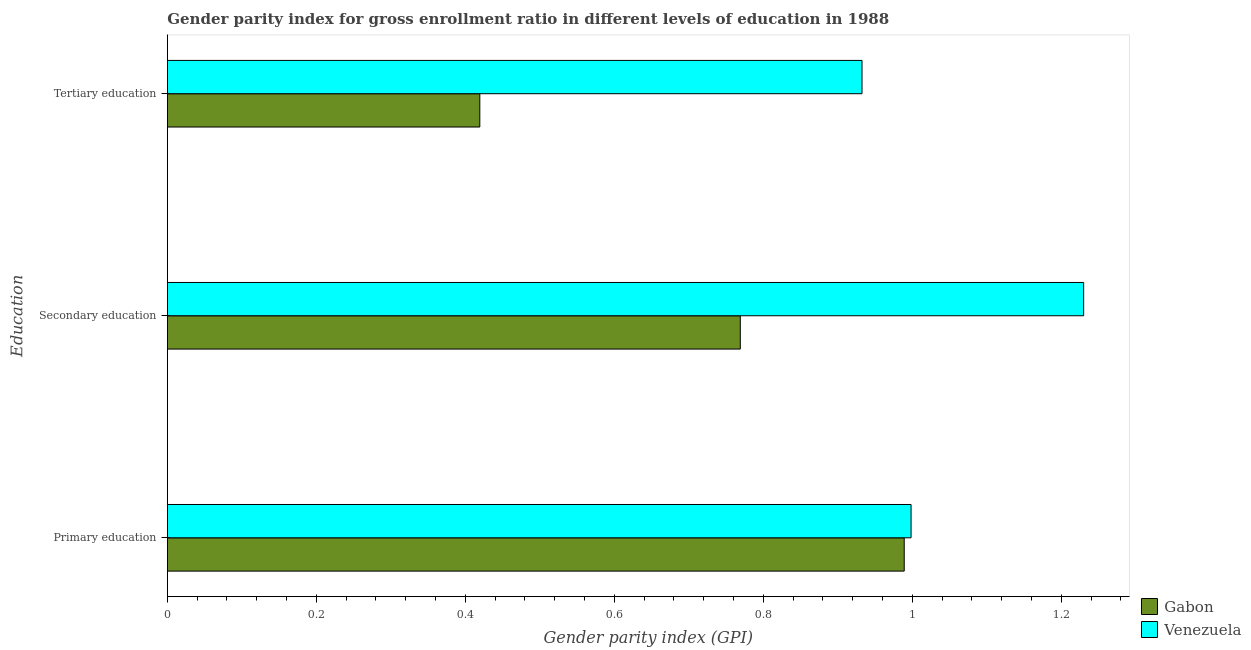How many groups of bars are there?
Offer a very short reply. 3. Are the number of bars on each tick of the Y-axis equal?
Provide a short and direct response. Yes. How many bars are there on the 1st tick from the top?
Your answer should be very brief. 2. What is the label of the 2nd group of bars from the top?
Provide a succinct answer. Secondary education. What is the gender parity index in primary education in Gabon?
Make the answer very short. 0.99. Across all countries, what is the maximum gender parity index in primary education?
Your response must be concise. 1. Across all countries, what is the minimum gender parity index in primary education?
Provide a short and direct response. 0.99. In which country was the gender parity index in primary education maximum?
Make the answer very short. Venezuela. In which country was the gender parity index in primary education minimum?
Keep it short and to the point. Gabon. What is the total gender parity index in primary education in the graph?
Provide a succinct answer. 1.99. What is the difference between the gender parity index in tertiary education in Gabon and that in Venezuela?
Provide a short and direct response. -0.51. What is the difference between the gender parity index in secondary education in Venezuela and the gender parity index in primary education in Gabon?
Offer a very short reply. 0.24. What is the average gender parity index in tertiary education per country?
Provide a short and direct response. 0.68. What is the difference between the gender parity index in secondary education and gender parity index in primary education in Venezuela?
Your answer should be very brief. 0.23. What is the ratio of the gender parity index in tertiary education in Gabon to that in Venezuela?
Your response must be concise. 0.45. Is the gender parity index in primary education in Gabon less than that in Venezuela?
Keep it short and to the point. Yes. What is the difference between the highest and the second highest gender parity index in secondary education?
Give a very brief answer. 0.46. What is the difference between the highest and the lowest gender parity index in tertiary education?
Your answer should be very brief. 0.51. What does the 1st bar from the top in Secondary education represents?
Provide a short and direct response. Venezuela. What does the 2nd bar from the bottom in Primary education represents?
Offer a very short reply. Venezuela. Is it the case that in every country, the sum of the gender parity index in primary education and gender parity index in secondary education is greater than the gender parity index in tertiary education?
Provide a short and direct response. Yes. How many bars are there?
Make the answer very short. 6. Are all the bars in the graph horizontal?
Give a very brief answer. Yes. How many countries are there in the graph?
Offer a very short reply. 2. Are the values on the major ticks of X-axis written in scientific E-notation?
Provide a succinct answer. No. How many legend labels are there?
Make the answer very short. 2. What is the title of the graph?
Give a very brief answer. Gender parity index for gross enrollment ratio in different levels of education in 1988. Does "Estonia" appear as one of the legend labels in the graph?
Offer a terse response. No. What is the label or title of the X-axis?
Your answer should be compact. Gender parity index (GPI). What is the label or title of the Y-axis?
Keep it short and to the point. Education. What is the Gender parity index (GPI) in Gabon in Primary education?
Provide a succinct answer. 0.99. What is the Gender parity index (GPI) in Venezuela in Primary education?
Provide a succinct answer. 1. What is the Gender parity index (GPI) of Gabon in Secondary education?
Offer a very short reply. 0.77. What is the Gender parity index (GPI) in Venezuela in Secondary education?
Offer a very short reply. 1.23. What is the Gender parity index (GPI) of Gabon in Tertiary education?
Provide a short and direct response. 0.42. What is the Gender parity index (GPI) of Venezuela in Tertiary education?
Your answer should be very brief. 0.93. Across all Education, what is the maximum Gender parity index (GPI) of Gabon?
Offer a terse response. 0.99. Across all Education, what is the maximum Gender parity index (GPI) in Venezuela?
Your answer should be very brief. 1.23. Across all Education, what is the minimum Gender parity index (GPI) of Gabon?
Your answer should be compact. 0.42. Across all Education, what is the minimum Gender parity index (GPI) in Venezuela?
Your answer should be compact. 0.93. What is the total Gender parity index (GPI) of Gabon in the graph?
Give a very brief answer. 2.18. What is the total Gender parity index (GPI) of Venezuela in the graph?
Provide a succinct answer. 3.16. What is the difference between the Gender parity index (GPI) in Gabon in Primary education and that in Secondary education?
Ensure brevity in your answer.  0.22. What is the difference between the Gender parity index (GPI) in Venezuela in Primary education and that in Secondary education?
Provide a short and direct response. -0.23. What is the difference between the Gender parity index (GPI) of Gabon in Primary education and that in Tertiary education?
Keep it short and to the point. 0.57. What is the difference between the Gender parity index (GPI) in Venezuela in Primary education and that in Tertiary education?
Your answer should be compact. 0.07. What is the difference between the Gender parity index (GPI) of Gabon in Secondary education and that in Tertiary education?
Offer a terse response. 0.35. What is the difference between the Gender parity index (GPI) of Venezuela in Secondary education and that in Tertiary education?
Your answer should be compact. 0.3. What is the difference between the Gender parity index (GPI) of Gabon in Primary education and the Gender parity index (GPI) of Venezuela in Secondary education?
Keep it short and to the point. -0.24. What is the difference between the Gender parity index (GPI) of Gabon in Primary education and the Gender parity index (GPI) of Venezuela in Tertiary education?
Provide a short and direct response. 0.06. What is the difference between the Gender parity index (GPI) of Gabon in Secondary education and the Gender parity index (GPI) of Venezuela in Tertiary education?
Provide a succinct answer. -0.16. What is the average Gender parity index (GPI) in Gabon per Education?
Keep it short and to the point. 0.73. What is the average Gender parity index (GPI) in Venezuela per Education?
Ensure brevity in your answer.  1.05. What is the difference between the Gender parity index (GPI) of Gabon and Gender parity index (GPI) of Venezuela in Primary education?
Offer a terse response. -0.01. What is the difference between the Gender parity index (GPI) of Gabon and Gender parity index (GPI) of Venezuela in Secondary education?
Keep it short and to the point. -0.46. What is the difference between the Gender parity index (GPI) of Gabon and Gender parity index (GPI) of Venezuela in Tertiary education?
Your answer should be compact. -0.51. What is the ratio of the Gender parity index (GPI) of Gabon in Primary education to that in Secondary education?
Your response must be concise. 1.29. What is the ratio of the Gender parity index (GPI) in Venezuela in Primary education to that in Secondary education?
Your response must be concise. 0.81. What is the ratio of the Gender parity index (GPI) in Gabon in Primary education to that in Tertiary education?
Provide a short and direct response. 2.36. What is the ratio of the Gender parity index (GPI) in Venezuela in Primary education to that in Tertiary education?
Give a very brief answer. 1.07. What is the ratio of the Gender parity index (GPI) in Gabon in Secondary education to that in Tertiary education?
Give a very brief answer. 1.83. What is the ratio of the Gender parity index (GPI) of Venezuela in Secondary education to that in Tertiary education?
Your answer should be compact. 1.32. What is the difference between the highest and the second highest Gender parity index (GPI) in Gabon?
Make the answer very short. 0.22. What is the difference between the highest and the second highest Gender parity index (GPI) of Venezuela?
Provide a short and direct response. 0.23. What is the difference between the highest and the lowest Gender parity index (GPI) in Gabon?
Offer a terse response. 0.57. What is the difference between the highest and the lowest Gender parity index (GPI) of Venezuela?
Your answer should be very brief. 0.3. 